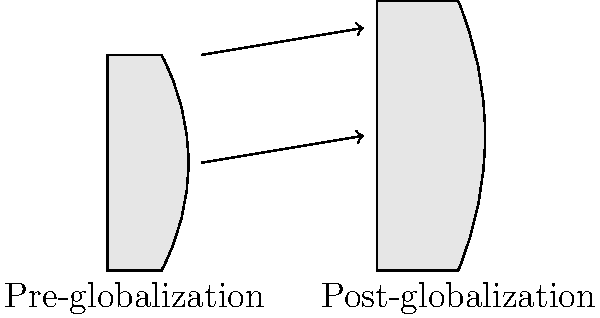Based on the simple outline drawings, how has globalization influenced the shape of traditional Okinawan pottery? To answer this question, let's analyze the changes in the pottery shapes:

1. Height: The post-globalization pottery appears taller than the pre-globalization version. This could indicate an influence from international markets preferring taller, more elongated forms.

2. Width: The post-globalization pottery has a wider base and overall wider profile. This might suggest an adaptation to different functional needs or aesthetic preferences introduced through global exchange.

3. Curvature: The post-globalization pottery shows a more pronounced curve in its profile, with a more defined "shoulder" area. This could reflect influences from other pottery traditions or modern design trends.

4. Proportions: The ratio of height to width has changed, with the post-globalization pottery appearing more elongated. This might indicate a shift towards forms that are considered more "elegant" or "modern" in a global context.

5. Rim: The rim of the post-globalization pottery seems slightly wider, which could suggest adaptations for different uses or pouring techniques influenced by global culinary practices.

These changes likely reflect a combination of factors, including:
- Exposure to international pottery styles and techniques
- Changing market demands from both local and global consumers
- Adaptation of traditional forms to suit modern lifestyles
- Incorporation of new materials or production methods introduced through globalization

The evolution of these shapes demonstrates how traditional Okinawan pottery has responded to global influences while maintaining its core form and identity.
Answer: Taller, wider, more curved profile with altered proportions 